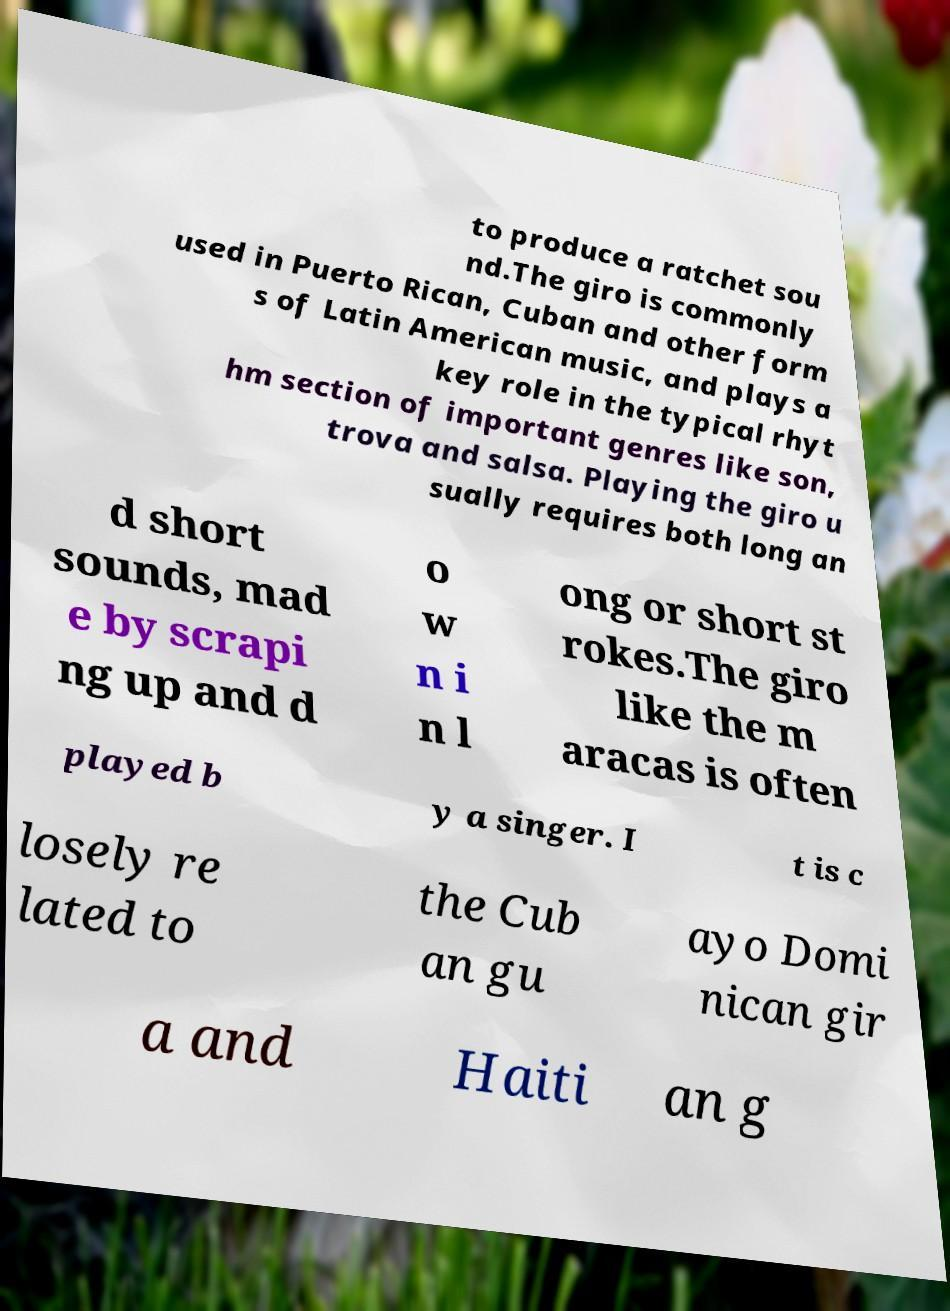Please identify and transcribe the text found in this image. to produce a ratchet sou nd.The giro is commonly used in Puerto Rican, Cuban and other form s of Latin American music, and plays a key role in the typical rhyt hm section of important genres like son, trova and salsa. Playing the giro u sually requires both long an d short sounds, mad e by scrapi ng up and d o w n i n l ong or short st rokes.The giro like the m aracas is often played b y a singer. I t is c losely re lated to the Cub an gu ayo Domi nican gir a and Haiti an g 